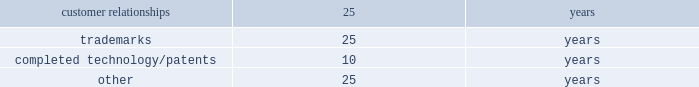Intangible assets such as patents , customer-related intangible assets and other intangible assets with finite useful lives are amortized on a straight-line basis over their estimated economic lives .
The weighted-average useful lives approximate the following: .
Recoverability of intangible assets with finite useful lives is assessed in the same manner as property , plant and equipment as described above .
Income taxes : for purposes of the company 2019s consolidated financial statements for periods prior to the spin-off , income tax expense has been recorded as if the company filed tax returns on a stand-alone basis separate from ingersoll rand .
This separate return methodology applies the accounting guidance for income taxes to the stand-alone financial statements as if the company was a stand-alone enterprise for the periods prior to the spin-off .
Therefore , cash tax payments and items of current and deferred taxes may not be reflective of the company 2019s actual tax balances prior to or subsequent to the spin-off .
Cash paid for income taxes , net of refunds for the twelve months ended december 31 , 2016 and 2015 was $ 10.4 million and $ 80.6 million , respectively .
The 2016 net cash income taxes paid includes a refund of $ 46.2 million received from the canadian tax authorities .
The income tax accounts reflected in the consolidated balance sheet as of december 31 , 2016 and 2015 include income taxes payable and deferred taxes allocated to the company at the time of the spin-off .
The calculation of the company 2019s income taxes involves considerable judgment and the use of both estimates and allocations .
Deferred tax assets and liabilities are determined based on temporary differences between financial reporting and tax bases of assets and liabilities , applying enacted tax rates expected to be in effect for the year in which the differences are expected to reverse .
The company recognizes future tax benefits , such as net operating losses and tax credits , to the extent that realizing these benefits is considered in its judgment to be more likely than not .
The company regularly reviews the recoverability of its deferred tax assets considering its historic profitability , projected future taxable income , timing of the reversals of existing temporary differences and the feasibility of its tax planning strategies .
Where appropriate , the company records a valuation allowance with respect to a future tax benefit .
Product warranties : standard product warranty accruals are recorded at the time of sale and are estimated based upon product warranty terms and historical experience .
The company assesses the adequacy of its liabilities and will make adjustments as necessary based on known or anticipated warranty claims , or as new information becomes available .
Revenue recognition : revenue is recognized and earned when all of the following criteria are satisfied : ( a ) persuasive evidence of a sales arrangement exists ; ( b ) the price is fixed or determinable ; ( c ) collectability is reasonably assured ; and ( d ) delivery has occurred or service has been rendered .
Delivery generally occurs when the title and the risks and rewards of ownership have transferred to the customer .
Both the persuasive evidence of a sales arrangement and fixed or determinable price criteria are deemed to be satisfied upon receipt of an executed and legally binding sales agreement or contract that clearly defines the terms and conditions of the transaction including the respective obligations of the parties .
If the defined terms and conditions allow variability in all or a component of the price , revenue is not recognized until such time that the price becomes fixed or determinable .
At the point of sale , the company validates the existence of an enforceable claim that requires payment within a reasonable amount of time and assesses the collectability of that claim .
If collectability is not deemed to be reasonably assured , then revenue recognition is deferred until such time that collectability becomes probable or cash is received .
Delivery is not considered to have occurred until the customer has taken title and assumed the risks and rewards of ownership .
Service and installation revenue are recognized when earned .
In some instances , customer acceptance provisions are included in sales arrangements to give the buyer the ability to ensure the delivered product or service meets the criteria established in the order .
In these instances , revenue recognition is deferred until the acceptance terms specified in the arrangement are fulfilled through customer acceptance or a demonstration that established criteria have been satisfied .
If uncertainty exists about customer acceptance , revenue is not recognized until acceptance has occurred .
The company offers various sales incentive programs to our customers , dealers , and distributors .
Sales incentive programs do not preclude revenue recognition , but do require an accrual for the company 2019s best estimate of expected activity .
Examples of the sales incentives that are accrued for as a contra receivable and sales deduction at the point of sale include , but are not limited to , discounts ( i.e .
Net 30 type ) , coupons , and rebates where the customer does not have to provide any additional requirements to receive the discount .
Sales returns and customer disputes involving a question of quantity or price are also accounted for as a .
What is the percentage of the refund received from the canadian tax authorities , in comparison with the total net cash income taxes paid in 2016? 
Rationale: it is the value of the refund received divided by the total net cash income taxes , then turned into a percentage.\\n
Computations: (46.2 / 80.6)
Answer: 0.5732. 